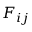<formula> <loc_0><loc_0><loc_500><loc_500>F _ { i j }</formula> 